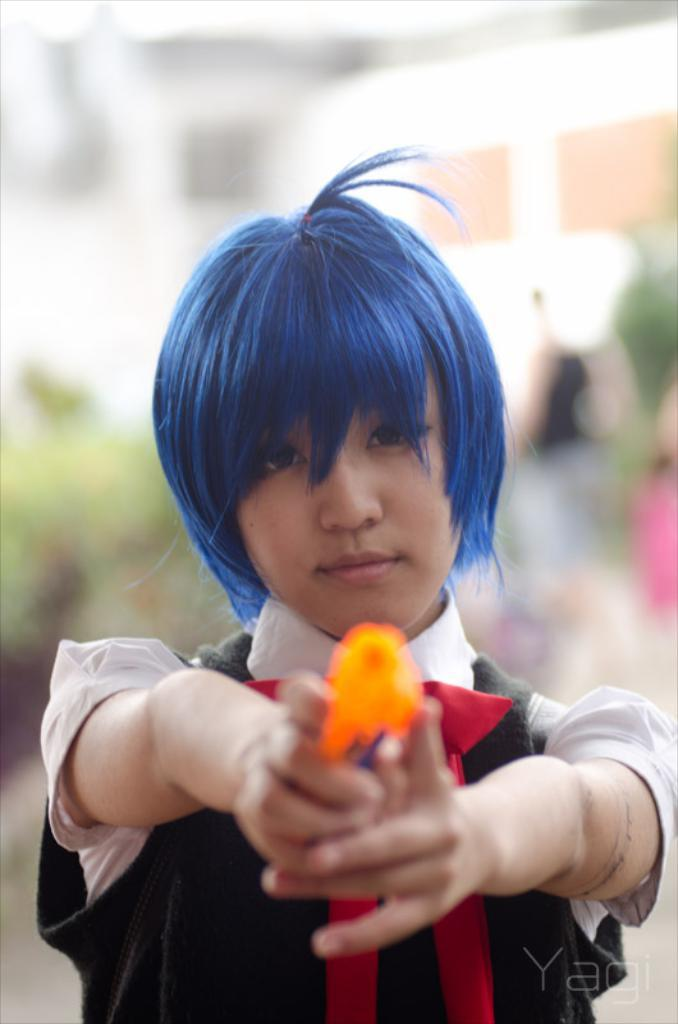Who is the main subject in the image? There is a woman in the image. What is the woman holding in the image? The woman is holding an orange object. Can you describe the woman's clothing in the image? The woman is wearing a dress with white, red, and black colors. How would you describe the background of the image? The background of the image is blurred. What type of steel is the goose made of in the image? There is no goose present in the image, and therefore no steel or any other material can be associated with it. 